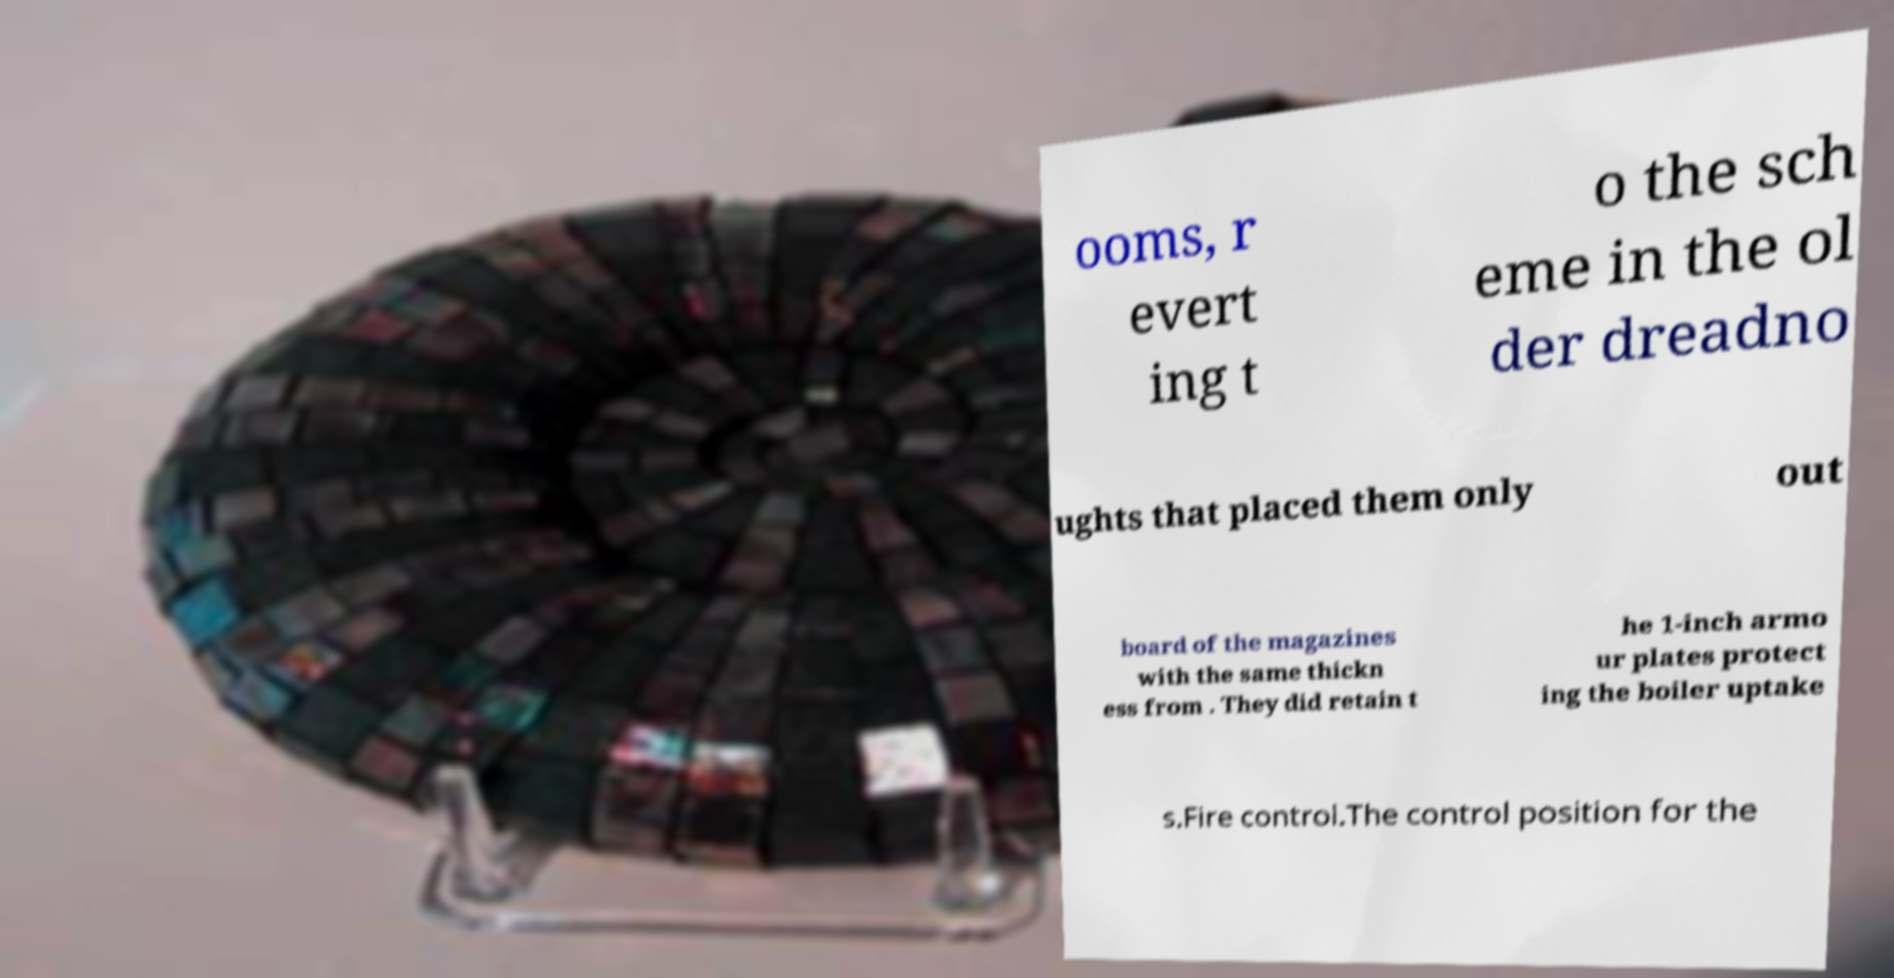Can you read and provide the text displayed in the image?This photo seems to have some interesting text. Can you extract and type it out for me? ooms, r evert ing t o the sch eme in the ol der dreadno ughts that placed them only out board of the magazines with the same thickn ess from . They did retain t he 1-inch armo ur plates protect ing the boiler uptake s.Fire control.The control position for the 